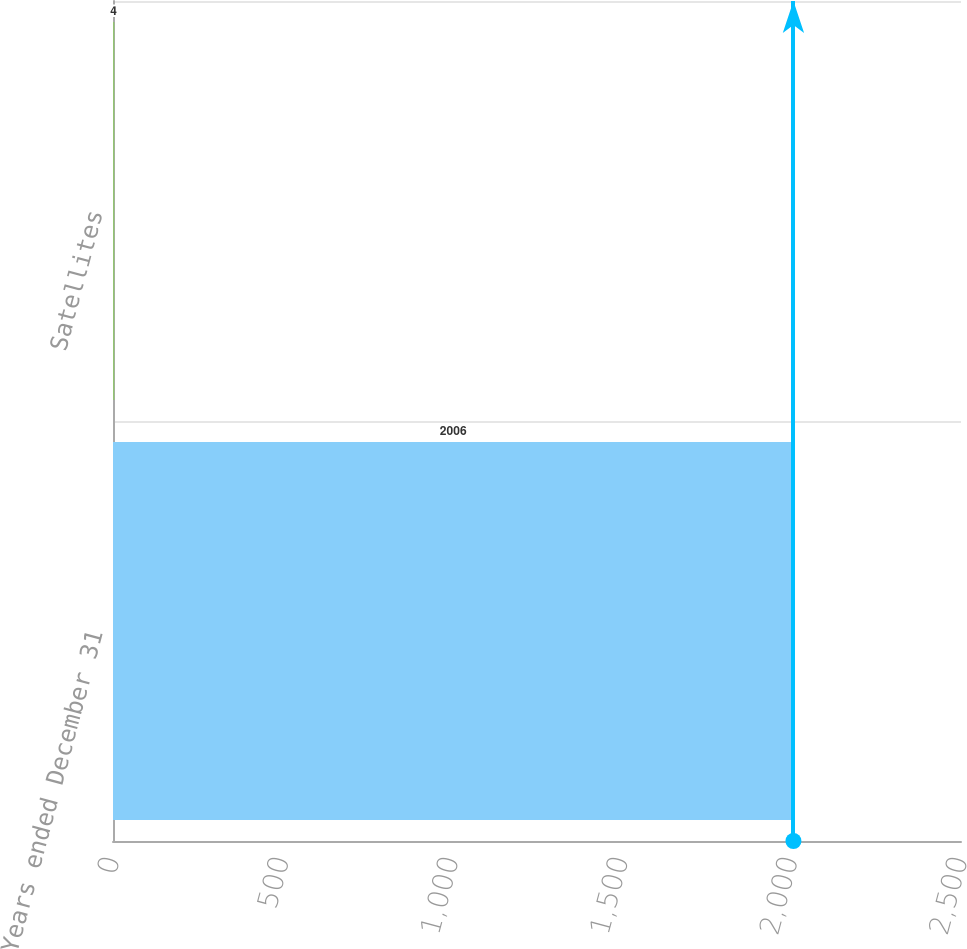<chart> <loc_0><loc_0><loc_500><loc_500><bar_chart><fcel>Years ended December 31<fcel>Satellites<nl><fcel>2006<fcel>4<nl></chart> 